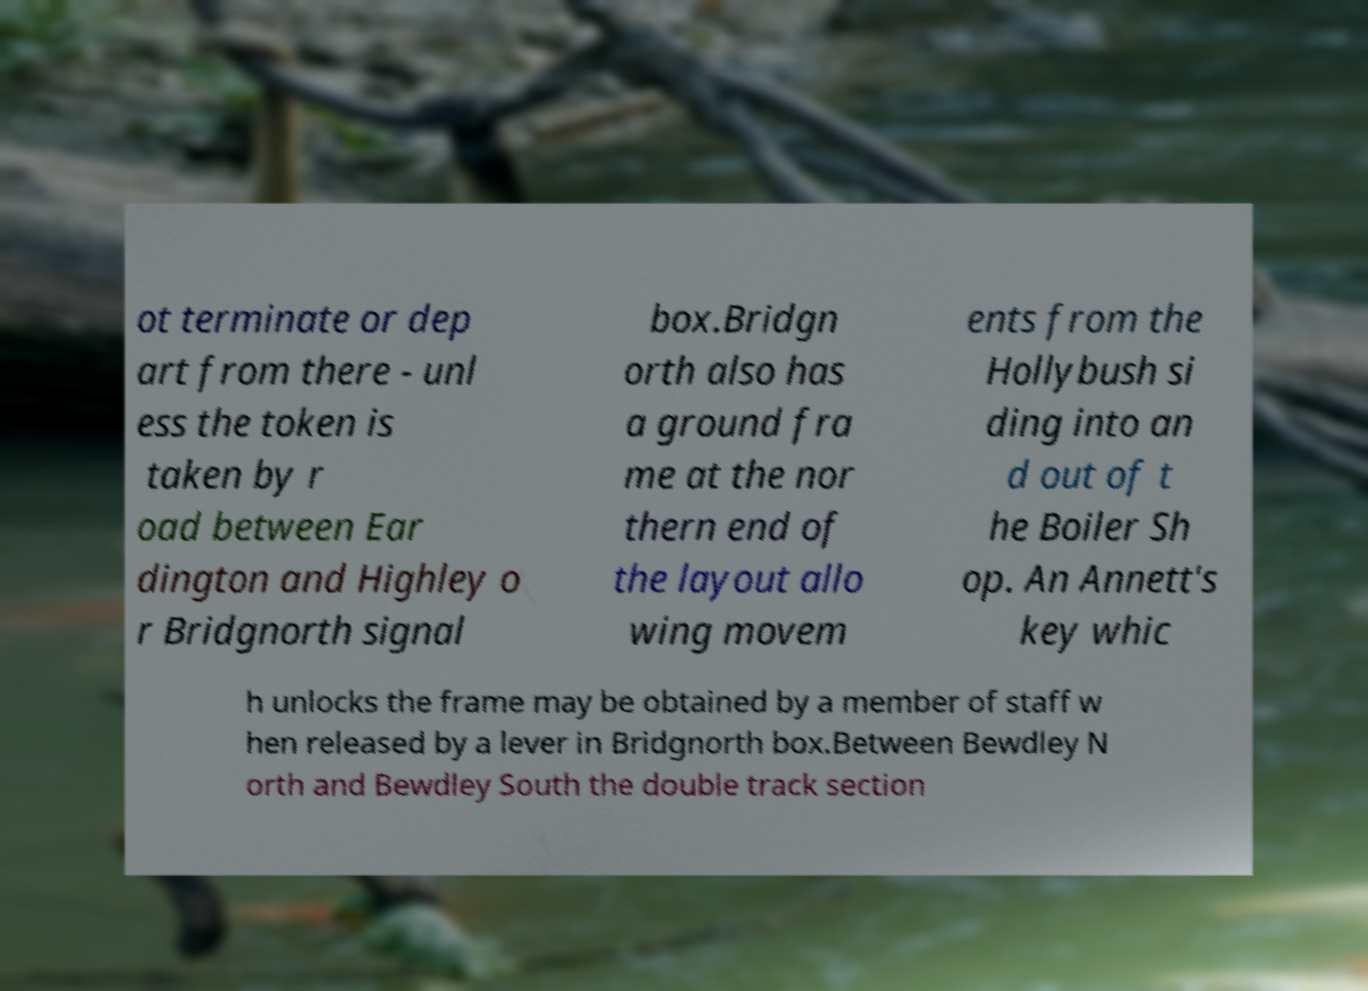Can you read and provide the text displayed in the image?This photo seems to have some interesting text. Can you extract and type it out for me? ot terminate or dep art from there - unl ess the token is taken by r oad between Ear dington and Highley o r Bridgnorth signal box.Bridgn orth also has a ground fra me at the nor thern end of the layout allo wing movem ents from the Hollybush si ding into an d out of t he Boiler Sh op. An Annett's key whic h unlocks the frame may be obtained by a member of staff w hen released by a lever in Bridgnorth box.Between Bewdley N orth and Bewdley South the double track section 